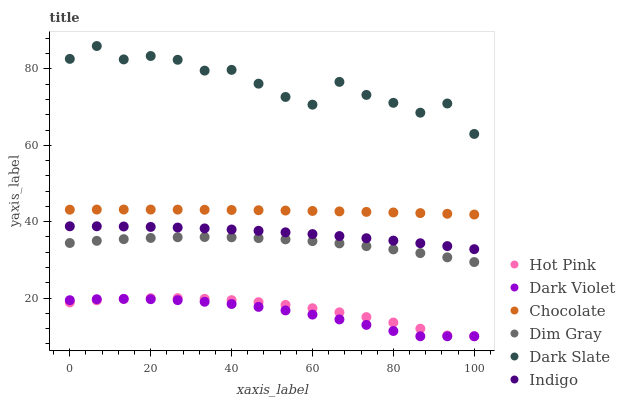Does Dark Violet have the minimum area under the curve?
Answer yes or no. Yes. Does Dark Slate have the maximum area under the curve?
Answer yes or no. Yes. Does Indigo have the minimum area under the curve?
Answer yes or no. No. Does Indigo have the maximum area under the curve?
Answer yes or no. No. Is Chocolate the smoothest?
Answer yes or no. Yes. Is Dark Slate the roughest?
Answer yes or no. Yes. Is Indigo the smoothest?
Answer yes or no. No. Is Indigo the roughest?
Answer yes or no. No. Does Hot Pink have the lowest value?
Answer yes or no. Yes. Does Indigo have the lowest value?
Answer yes or no. No. Does Dark Slate have the highest value?
Answer yes or no. Yes. Does Indigo have the highest value?
Answer yes or no. No. Is Hot Pink less than Dark Slate?
Answer yes or no. Yes. Is Chocolate greater than Dark Violet?
Answer yes or no. Yes. Does Dark Violet intersect Hot Pink?
Answer yes or no. Yes. Is Dark Violet less than Hot Pink?
Answer yes or no. No. Is Dark Violet greater than Hot Pink?
Answer yes or no. No. Does Hot Pink intersect Dark Slate?
Answer yes or no. No. 